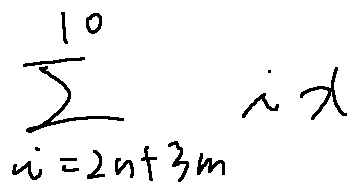Convert formula to latex. <formula><loc_0><loc_0><loc_500><loc_500>\sum \lim i t s _ { i = 2 n + 3 m } ^ { 1 0 } i x</formula> 